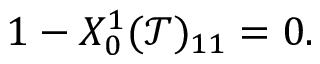Convert formula to latex. <formula><loc_0><loc_0><loc_500><loc_500>\begin{array} { r } { 1 - X _ { 0 } ^ { 1 } ( \mathcal { T } ) _ { 1 1 } = 0 . } \end{array}</formula> 